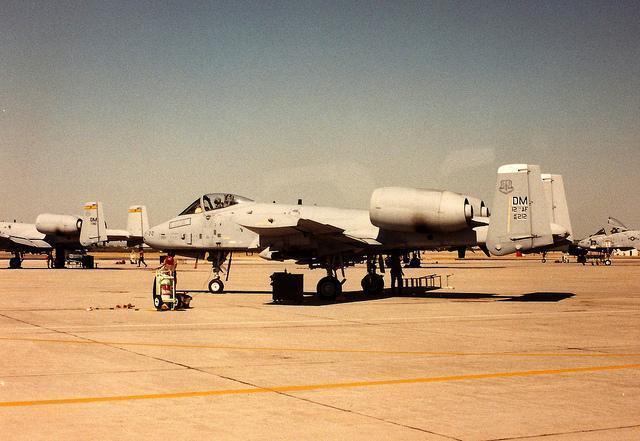How many people does this plane carry?
Give a very brief answer. 2. How many airplanes are there?
Give a very brief answer. 2. How many boys take the pizza in the image?
Give a very brief answer. 0. 